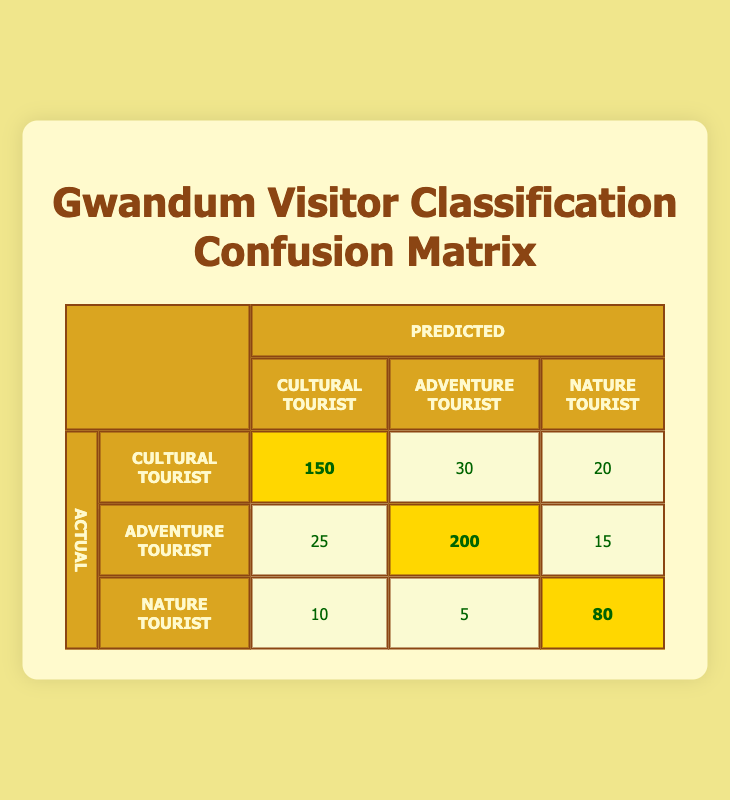What is the number of predicted Cultural Tourists who were actually Cultural Tourists? The table shows that the count for predicted Cultural Tourists and actual Cultural Tourists is 150. Thus, the answer is directly found in that cell of the matrix.
Answer: 150 What is the total number of Adventure Tourists predicted? To find this, we need to sum the counts of predicted Adventure Tourists from both the actual Adventure and Cultural Tourist rows. The counts are 200 (from Adventure Tourist) + 30 (from Cultural Tourist) = 230.
Answer: 230 Are there more actual Nature Tourists predicted as Cultural Tourists than those predicted as Adventure Tourists? The table shows 10 Nature Tourists predicted as Cultural and 5 as Adventure. Here, 10 > 5 is a true statement.
Answer: Yes What is the total number of Nature Tourists, according to their actual classification? The total is calculated by summing the counts of Nature Tourists in all columns where they are classified as Nature. That's 80 (predicted Nature Tourist) + 10 (predicted as Cultural) + 5 (predicted as Adventure) = 95.
Answer: 95 What is the predicted accuracy for Cultural Tourists? Accuracy can be calculated as the number of true predictions (Cultural Tourists predicted correctly = 150) divided by the total number of Cultural Tourist predictions made (150 + 30 + 20 = 200). Hence, the accuracy is 150/200 = 0.75 or 75%.
Answer: 75% In the table, how many Adventure Tourists were incorrectly classified as Cultural Tourists? Looking at the confusion matrix, we see that 25 Adventure Tourists were predicted as Cultural Tourists. This number tells us how many were incorrectly classified in this category.
Answer: 25 What is the number of predictions where Nature Tourists were predicted correctly? Referring to the table, we see that Nature Tourists predicted correctly is 80 (Nature as Nature). Since we only need that one cell value, it directly gives us the answer.
Answer: 80 How many Adventure Tourists were classified as Nature Tourists? Looking at the confusion matrix, 15 Adventure Tourists were predicted as Nature Tourists. This is directly available from that cell in the matrix.
Answer: 15 What fraction of total predictions were Cultural Tourists correctly classified? The total number of predictions is the sum of all counts: 150 + 30 + 20 + 25 + 200 + 15 + 10 + 5 + 80 = 535. The correct Cultural Tourist classifications are 150. Dividing gives us 150/535, which simplifies to approximately 0.28 or 28%.
Answer: 28% 